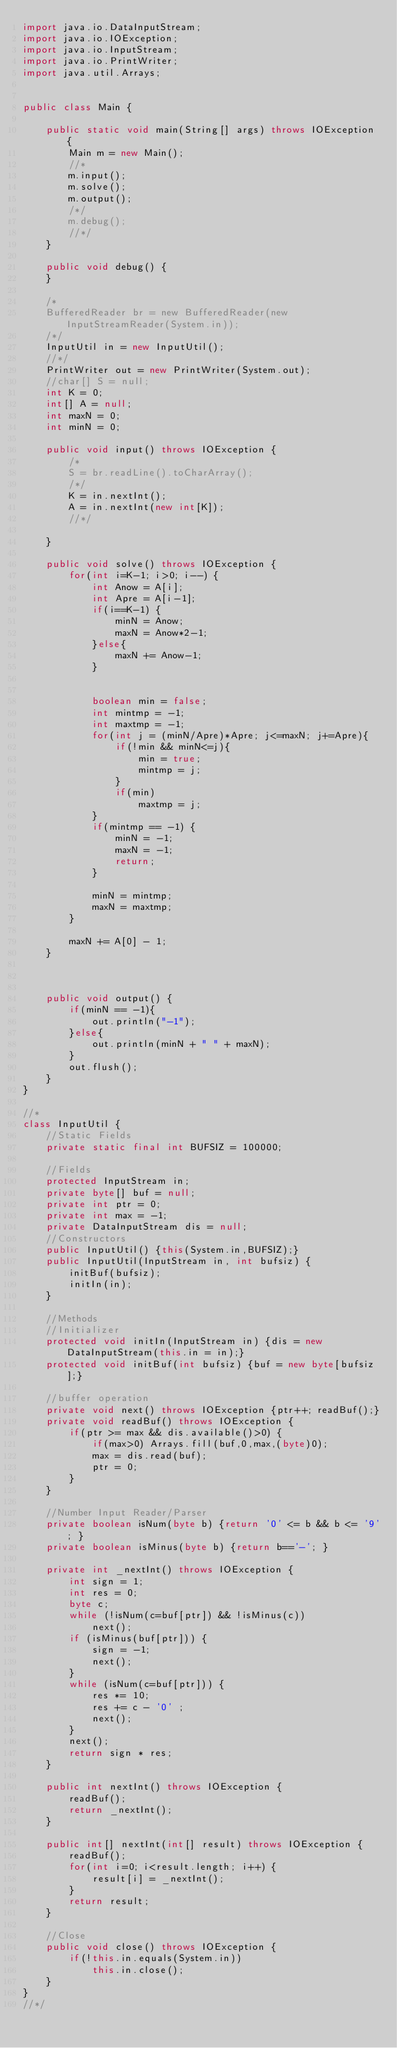Convert code to text. <code><loc_0><loc_0><loc_500><loc_500><_Java_>import java.io.DataInputStream;
import java.io.IOException;
import java.io.InputStream;
import java.io.PrintWriter;
import java.util.Arrays;
 
 
public class Main {
	
	public static void main(String[] args) throws IOException {
		Main m = new Main();
		//*
		m.input();
		m.solve();
		m.output();
		/*/
		m.debug();
		//*/
	}
	
	public void debug() {
	}
	
	/*
	BufferedReader br = new BufferedReader(new InputStreamReader(System.in));
	/*/
	InputUtil in = new InputUtil();
	//*/
	PrintWriter out = new PrintWriter(System.out);
	//char[] S = null;
	int K = 0;
	int[] A = null;
	int maxN = 0;
	int minN = 0;
	
	public void input() throws IOException {
		/*
		S = br.readLine().toCharArray();
		/*/
		K = in.nextInt();
		A = in.nextInt(new int[K]);
		//*/
		
	}

	public void solve() throws IOException {
		for(int i=K-1; i>0; i--) {
			int Anow = A[i];
			int Apre = A[i-1];
			if(i==K-1) {
				minN = Anow;
				maxN = Anow*2-1;
			}else{
				maxN += Anow-1;
			}
			
			
			boolean min = false;
			int mintmp = -1;
			int maxtmp = -1;
			for(int j = (minN/Apre)*Apre; j<=maxN; j+=Apre){
				if(!min && minN<=j){
					min = true;
					mintmp = j;
				}
				if(min)
					maxtmp = j;
			}
			if(mintmp == -1) {
				minN = -1;
				maxN = -1;
				return;
			}
			
			minN = mintmp;
			maxN = maxtmp;
		}
		
		maxN += A[0] - 1;
	}
	
	
	
	public void output() {
		if(minN == -1){
			out.println("-1");
		}else{
			out.println(minN + " " + maxN);
		}
		out.flush();
	}
}

//*
class InputUtil {
	//Static Fields
	private static final int BUFSIZ = 100000;
	
	//Fields
	protected InputStream in;
	private byte[] buf = null;
	private int ptr = 0;
	private int max = -1;
	private DataInputStream dis = null;
	//Constructors
	public InputUtil() {this(System.in,BUFSIZ);}
	public InputUtil(InputStream in, int bufsiz) {
		initBuf(bufsiz);
		initIn(in);
	}
	
	//Methods
	//Initializer
	protected void initIn(InputStream in) {dis = new DataInputStream(this.in = in);}
	protected void initBuf(int bufsiz) {buf = new byte[bufsiz];}
	
	//buffer operation
	private void next() throws IOException {ptr++; readBuf();}
	private void readBuf() throws IOException {
		if(ptr >= max && dis.available()>0) {
			if(max>0) Arrays.fill(buf,0,max,(byte)0);
			max = dis.read(buf);
			ptr = 0;
		}
	}
	
	//Number Input Reader/Parser
	private boolean isNum(byte b) {return '0' <= b && b <= '9'; }
	private boolean isMinus(byte b) {return b=='-'; }
 
	private int _nextInt() throws IOException {
		int sign = 1;
		int res = 0;
		byte c;
		while (!isNum(c=buf[ptr]) && !isMinus(c)) 
			next();
		if (isMinus(buf[ptr])) {
			sign = -1;
			next();
		}
		while (isNum(c=buf[ptr])) {
			res *= 10;
			res += c - '0' ;
			next();
		}
		next();
		return sign * res;
	}
	
	public int nextInt() throws IOException {
		readBuf();
		return _nextInt();
	}
 
	public int[] nextInt(int[] result) throws IOException {
		readBuf();
		for(int i=0; i<result.length; i++) {
			result[i] = _nextInt();
		}
		return result;
	}
	
	//Close 
	public void close() throws IOException {
		if(!this.in.equals(System.in)) 
			this.in.close();
	}
}
//*/
</code> 